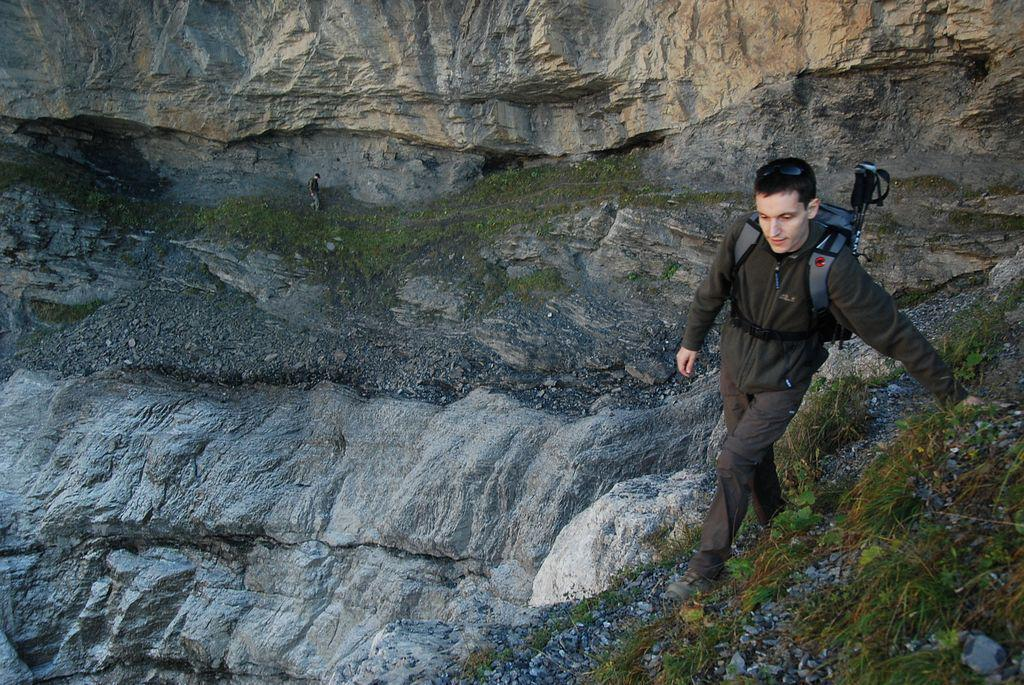What is the main subject of the image? There is a man walking in the center of the image. What type of surface is the man walking on? The man is walking on grass, which can be seen on the right side of the image. Can you describe the background of the image? There is a person in the background of the image, and there is also grass on the ground in the background. What type of book is the man carrying in the image? There is no book visible in the image; the man is simply walking. What kind of toys can be seen in the background of the image? There are no toys present in the image; it features a man walking and a person in the background. 